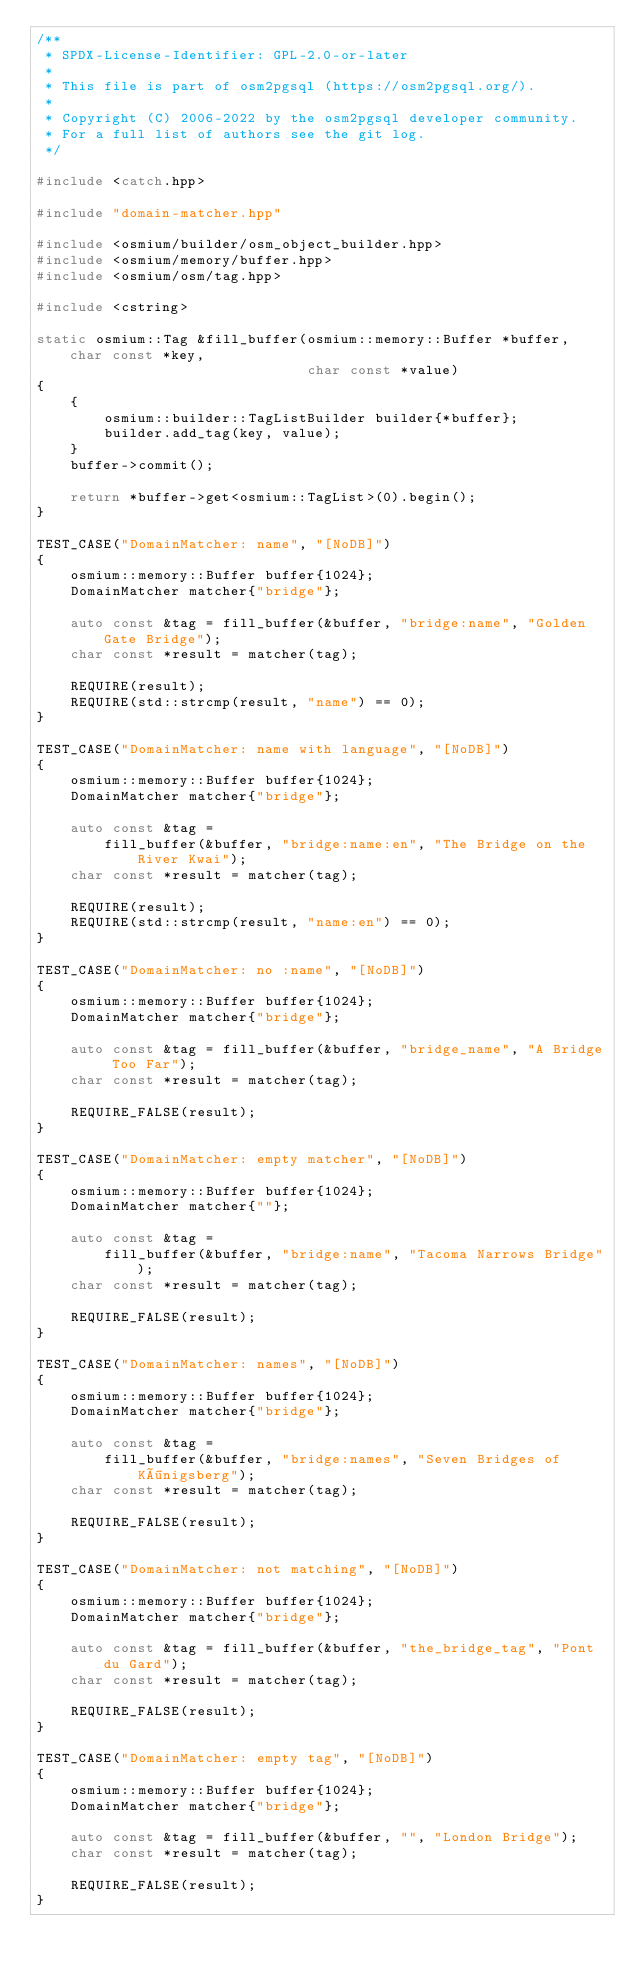<code> <loc_0><loc_0><loc_500><loc_500><_C++_>/**
 * SPDX-License-Identifier: GPL-2.0-or-later
 *
 * This file is part of osm2pgsql (https://osm2pgsql.org/).
 *
 * Copyright (C) 2006-2022 by the osm2pgsql developer community.
 * For a full list of authors see the git log.
 */

#include <catch.hpp>

#include "domain-matcher.hpp"

#include <osmium/builder/osm_object_builder.hpp>
#include <osmium/memory/buffer.hpp>
#include <osmium/osm/tag.hpp>

#include <cstring>

static osmium::Tag &fill_buffer(osmium::memory::Buffer *buffer, char const *key,
                                char const *value)
{
    {
        osmium::builder::TagListBuilder builder{*buffer};
        builder.add_tag(key, value);
    }
    buffer->commit();

    return *buffer->get<osmium::TagList>(0).begin();
}

TEST_CASE("DomainMatcher: name", "[NoDB]")
{
    osmium::memory::Buffer buffer{1024};
    DomainMatcher matcher{"bridge"};

    auto const &tag = fill_buffer(&buffer, "bridge:name", "Golden Gate Bridge");
    char const *result = matcher(tag);

    REQUIRE(result);
    REQUIRE(std::strcmp(result, "name") == 0);
}

TEST_CASE("DomainMatcher: name with language", "[NoDB]")
{
    osmium::memory::Buffer buffer{1024};
    DomainMatcher matcher{"bridge"};

    auto const &tag =
        fill_buffer(&buffer, "bridge:name:en", "The Bridge on the River Kwai");
    char const *result = matcher(tag);

    REQUIRE(result);
    REQUIRE(std::strcmp(result, "name:en") == 0);
}

TEST_CASE("DomainMatcher: no :name", "[NoDB]")
{
    osmium::memory::Buffer buffer{1024};
    DomainMatcher matcher{"bridge"};

    auto const &tag = fill_buffer(&buffer, "bridge_name", "A Bridge Too Far");
    char const *result = matcher(tag);

    REQUIRE_FALSE(result);
}

TEST_CASE("DomainMatcher: empty matcher", "[NoDB]")
{
    osmium::memory::Buffer buffer{1024};
    DomainMatcher matcher{""};

    auto const &tag =
        fill_buffer(&buffer, "bridge:name", "Tacoma Narrows Bridge");
    char const *result = matcher(tag);

    REQUIRE_FALSE(result);
}

TEST_CASE("DomainMatcher: names", "[NoDB]")
{
    osmium::memory::Buffer buffer{1024};
    DomainMatcher matcher{"bridge"};

    auto const &tag =
        fill_buffer(&buffer, "bridge:names", "Seven Bridges of Königsberg");
    char const *result = matcher(tag);

    REQUIRE_FALSE(result);
}

TEST_CASE("DomainMatcher: not matching", "[NoDB]")
{
    osmium::memory::Buffer buffer{1024};
    DomainMatcher matcher{"bridge"};

    auto const &tag = fill_buffer(&buffer, "the_bridge_tag", "Pont du Gard");
    char const *result = matcher(tag);

    REQUIRE_FALSE(result);
}

TEST_CASE("DomainMatcher: empty tag", "[NoDB]")
{
    osmium::memory::Buffer buffer{1024};
    DomainMatcher matcher{"bridge"};

    auto const &tag = fill_buffer(&buffer, "", "London Bridge");
    char const *result = matcher(tag);

    REQUIRE_FALSE(result);
}
</code> 